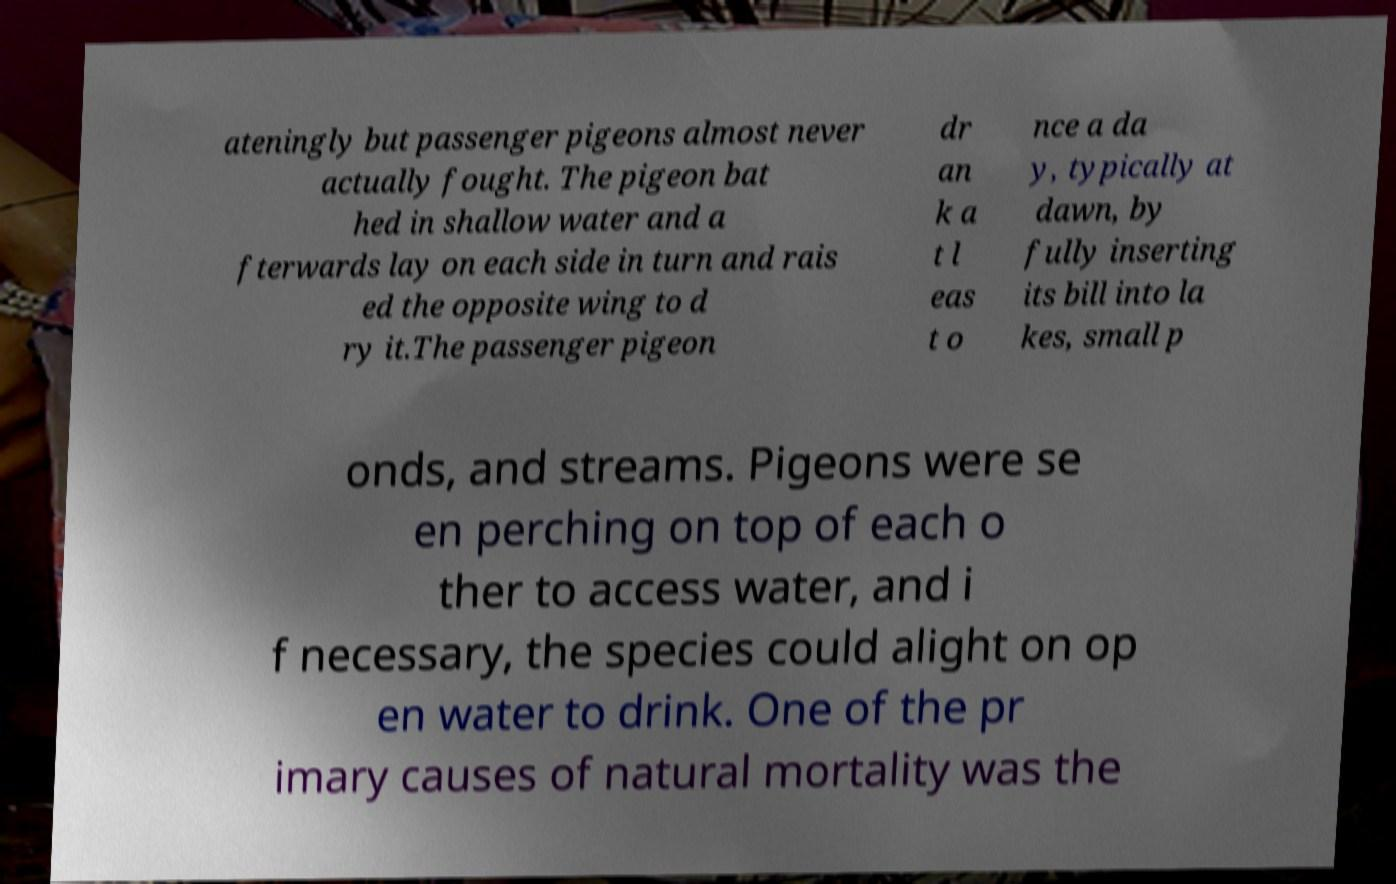Can you accurately transcribe the text from the provided image for me? ateningly but passenger pigeons almost never actually fought. The pigeon bat hed in shallow water and a fterwards lay on each side in turn and rais ed the opposite wing to d ry it.The passenger pigeon dr an k a t l eas t o nce a da y, typically at dawn, by fully inserting its bill into la kes, small p onds, and streams. Pigeons were se en perching on top of each o ther to access water, and i f necessary, the species could alight on op en water to drink. One of the pr imary causes of natural mortality was the 